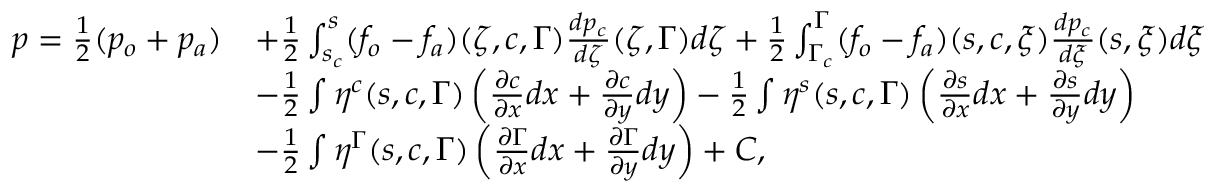Convert formula to latex. <formula><loc_0><loc_0><loc_500><loc_500>\begin{array} { r l } { p = \frac { 1 } { 2 } ( p _ { o } + p _ { a } ) } & { + \frac { 1 } { 2 } \int _ { s _ { c } } ^ { s } ( f _ { o } - f _ { a } ) ( \zeta , c , \Gamma ) \frac { d p _ { c } } { d \zeta } ( \zeta , \Gamma ) d \zeta + \frac { 1 } { 2 } \int _ { \Gamma _ { c } } ^ { \Gamma } ( f _ { o } - f _ { a } ) ( s , c , \xi ) \frac { d p _ { c } } { d \xi } ( s , \xi ) d \xi } \\ & { - \frac { 1 } { 2 } \int \eta ^ { c } ( s , c , \Gamma ) \left ( { \frac { \partial c } { \partial x } } d x + { \frac { \partial c } { \partial y } } d y \right ) - \frac { 1 } { 2 } \int \eta ^ { s } ( s , c , \Gamma ) \left ( { \frac { \partial s } { \partial x } } d x + { \frac { \partial s } { \partial y } } d y \right ) } \\ & { - \frac { 1 } { 2 } \int \eta ^ { \Gamma } ( s , c , \Gamma ) \left ( { \frac { \partial \Gamma } { \partial x } } d x + { \frac { \partial \Gamma } { \partial y } } d y \right ) + C , } \end{array}</formula> 